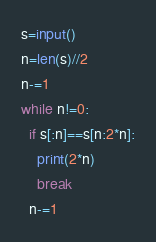<code> <loc_0><loc_0><loc_500><loc_500><_Python_>s=input()
n=len(s)//2
n-=1
while n!=0:
  if s[:n]==s[n:2*n]:
    print(2*n)
    break
  n-=1</code> 